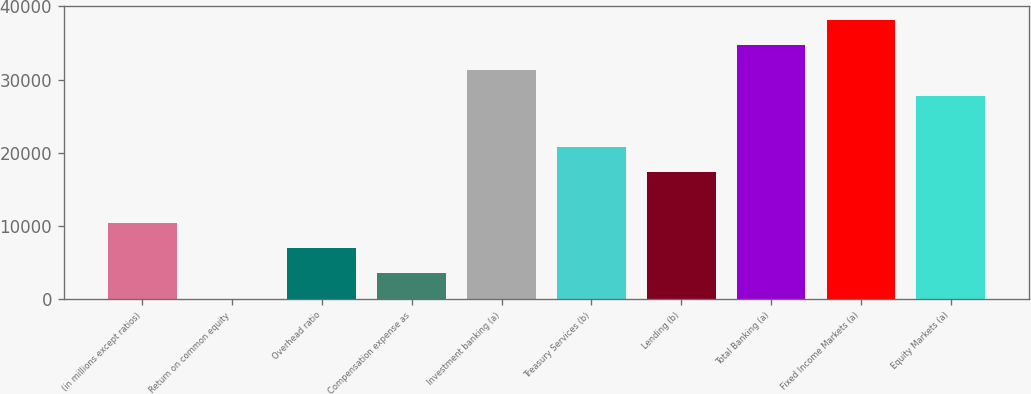Convert chart to OTSL. <chart><loc_0><loc_0><loc_500><loc_500><bar_chart><fcel>(in millions except ratios)<fcel>Return on common equity<fcel>Overhead ratio<fcel>Compensation expense as<fcel>Investment banking (a)<fcel>Treasury Services (b)<fcel>Lending (b)<fcel>Total Banking (a)<fcel>Fixed Income Markets (a)<fcel>Equity Markets (a)<nl><fcel>10424.1<fcel>15<fcel>6954.4<fcel>3484.7<fcel>31242.3<fcel>20833.2<fcel>17363.5<fcel>34712<fcel>38181.7<fcel>27772.6<nl></chart> 